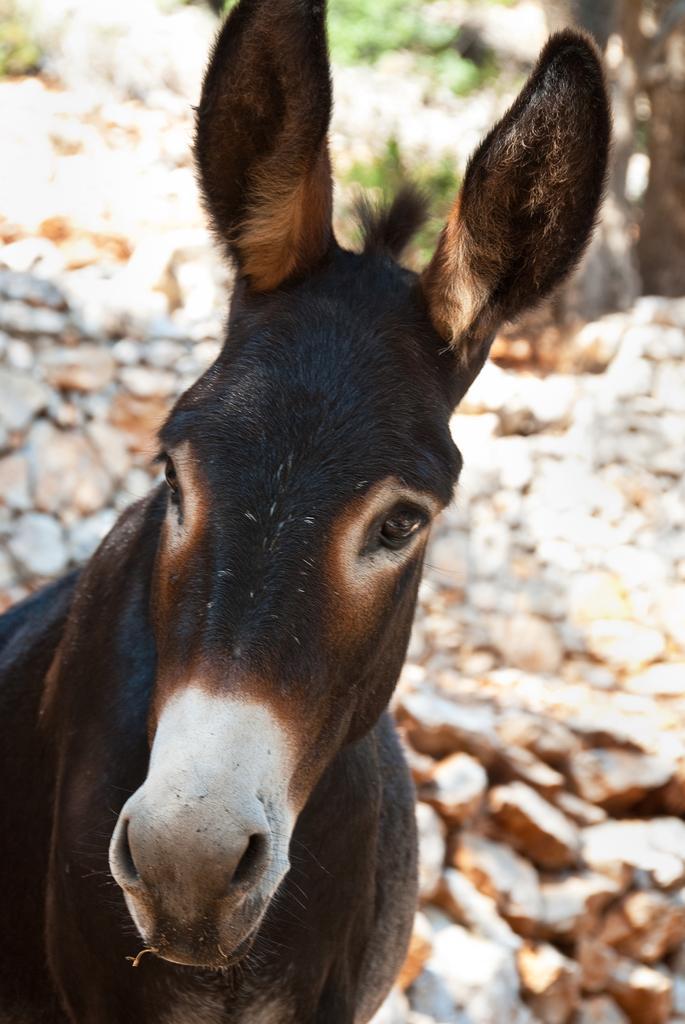Describe this image in one or two sentences. In this image we can see an animal, there are rocks, plants, also the background is blurred. 